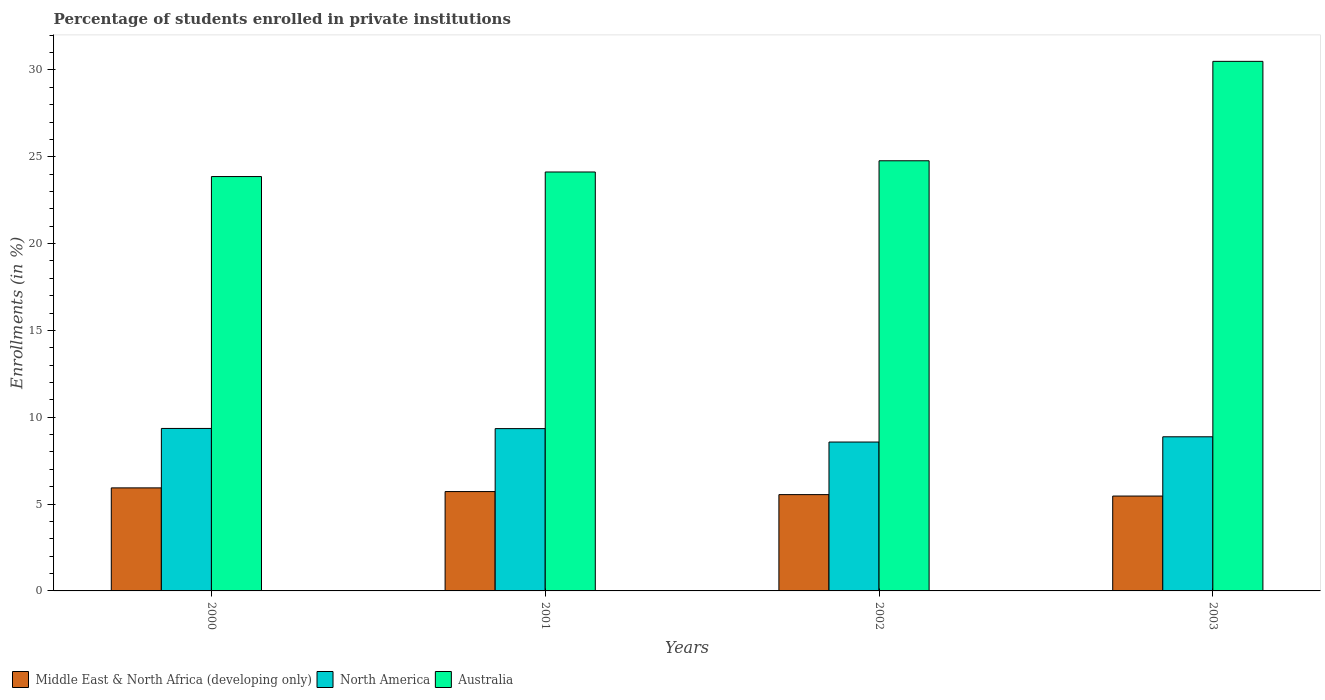How many groups of bars are there?
Your answer should be very brief. 4. How many bars are there on the 3rd tick from the left?
Your answer should be very brief. 3. How many bars are there on the 4th tick from the right?
Provide a succinct answer. 3. What is the label of the 2nd group of bars from the left?
Make the answer very short. 2001. In how many cases, is the number of bars for a given year not equal to the number of legend labels?
Give a very brief answer. 0. What is the percentage of trained teachers in Australia in 2000?
Make the answer very short. 23.86. Across all years, what is the maximum percentage of trained teachers in Australia?
Offer a terse response. 30.49. Across all years, what is the minimum percentage of trained teachers in Middle East & North Africa (developing only)?
Provide a succinct answer. 5.46. In which year was the percentage of trained teachers in Australia maximum?
Ensure brevity in your answer.  2003. What is the total percentage of trained teachers in North America in the graph?
Provide a succinct answer. 36.15. What is the difference between the percentage of trained teachers in Middle East & North Africa (developing only) in 2002 and that in 2003?
Provide a short and direct response. 0.08. What is the difference between the percentage of trained teachers in North America in 2001 and the percentage of trained teachers in Australia in 2002?
Your answer should be very brief. -15.42. What is the average percentage of trained teachers in Middle East & North Africa (developing only) per year?
Make the answer very short. 5.67. In the year 2002, what is the difference between the percentage of trained teachers in Middle East & North Africa (developing only) and percentage of trained teachers in North America?
Your response must be concise. -3.03. What is the ratio of the percentage of trained teachers in Australia in 2000 to that in 2001?
Provide a succinct answer. 0.99. What is the difference between the highest and the second highest percentage of trained teachers in Australia?
Keep it short and to the point. 5.72. What is the difference between the highest and the lowest percentage of trained teachers in Middle East & North Africa (developing only)?
Provide a succinct answer. 0.47. Is the sum of the percentage of trained teachers in North America in 2000 and 2002 greater than the maximum percentage of trained teachers in Australia across all years?
Your response must be concise. No. What does the 2nd bar from the left in 2002 represents?
Make the answer very short. North America. What does the 2nd bar from the right in 2002 represents?
Keep it short and to the point. North America. Is it the case that in every year, the sum of the percentage of trained teachers in Australia and percentage of trained teachers in Middle East & North Africa (developing only) is greater than the percentage of trained teachers in North America?
Keep it short and to the point. Yes. How many years are there in the graph?
Ensure brevity in your answer.  4. What is the difference between two consecutive major ticks on the Y-axis?
Your answer should be very brief. 5. Does the graph contain grids?
Offer a very short reply. No. Where does the legend appear in the graph?
Your answer should be compact. Bottom left. How are the legend labels stacked?
Your response must be concise. Horizontal. What is the title of the graph?
Offer a very short reply. Percentage of students enrolled in private institutions. What is the label or title of the Y-axis?
Keep it short and to the point. Enrollments (in %). What is the Enrollments (in %) in Middle East & North Africa (developing only) in 2000?
Your response must be concise. 5.93. What is the Enrollments (in %) of North America in 2000?
Keep it short and to the point. 9.36. What is the Enrollments (in %) in Australia in 2000?
Ensure brevity in your answer.  23.86. What is the Enrollments (in %) in Middle East & North Africa (developing only) in 2001?
Offer a terse response. 5.72. What is the Enrollments (in %) of North America in 2001?
Your answer should be compact. 9.35. What is the Enrollments (in %) in Australia in 2001?
Provide a succinct answer. 24.12. What is the Enrollments (in %) in Middle East & North Africa (developing only) in 2002?
Your answer should be very brief. 5.55. What is the Enrollments (in %) of North America in 2002?
Keep it short and to the point. 8.57. What is the Enrollments (in %) of Australia in 2002?
Provide a succinct answer. 24.77. What is the Enrollments (in %) in Middle East & North Africa (developing only) in 2003?
Your answer should be very brief. 5.46. What is the Enrollments (in %) of North America in 2003?
Provide a short and direct response. 8.87. What is the Enrollments (in %) in Australia in 2003?
Ensure brevity in your answer.  30.49. Across all years, what is the maximum Enrollments (in %) of Middle East & North Africa (developing only)?
Your response must be concise. 5.93. Across all years, what is the maximum Enrollments (in %) of North America?
Provide a short and direct response. 9.36. Across all years, what is the maximum Enrollments (in %) in Australia?
Give a very brief answer. 30.49. Across all years, what is the minimum Enrollments (in %) of Middle East & North Africa (developing only)?
Make the answer very short. 5.46. Across all years, what is the minimum Enrollments (in %) of North America?
Ensure brevity in your answer.  8.57. Across all years, what is the minimum Enrollments (in %) of Australia?
Ensure brevity in your answer.  23.86. What is the total Enrollments (in %) of Middle East & North Africa (developing only) in the graph?
Ensure brevity in your answer.  22.66. What is the total Enrollments (in %) in North America in the graph?
Your answer should be very brief. 36.15. What is the total Enrollments (in %) in Australia in the graph?
Provide a succinct answer. 103.24. What is the difference between the Enrollments (in %) of Middle East & North Africa (developing only) in 2000 and that in 2001?
Ensure brevity in your answer.  0.21. What is the difference between the Enrollments (in %) in North America in 2000 and that in 2001?
Your answer should be very brief. 0.01. What is the difference between the Enrollments (in %) of Australia in 2000 and that in 2001?
Give a very brief answer. -0.26. What is the difference between the Enrollments (in %) of Middle East & North Africa (developing only) in 2000 and that in 2002?
Offer a terse response. 0.39. What is the difference between the Enrollments (in %) in North America in 2000 and that in 2002?
Keep it short and to the point. 0.78. What is the difference between the Enrollments (in %) of Australia in 2000 and that in 2002?
Keep it short and to the point. -0.91. What is the difference between the Enrollments (in %) of Middle East & North Africa (developing only) in 2000 and that in 2003?
Make the answer very short. 0.47. What is the difference between the Enrollments (in %) of North America in 2000 and that in 2003?
Provide a succinct answer. 0.48. What is the difference between the Enrollments (in %) in Australia in 2000 and that in 2003?
Ensure brevity in your answer.  -6.63. What is the difference between the Enrollments (in %) in Middle East & North Africa (developing only) in 2001 and that in 2002?
Your response must be concise. 0.18. What is the difference between the Enrollments (in %) in North America in 2001 and that in 2002?
Keep it short and to the point. 0.77. What is the difference between the Enrollments (in %) of Australia in 2001 and that in 2002?
Offer a very short reply. -0.65. What is the difference between the Enrollments (in %) of Middle East & North Africa (developing only) in 2001 and that in 2003?
Provide a succinct answer. 0.26. What is the difference between the Enrollments (in %) of North America in 2001 and that in 2003?
Give a very brief answer. 0.47. What is the difference between the Enrollments (in %) of Australia in 2001 and that in 2003?
Ensure brevity in your answer.  -6.37. What is the difference between the Enrollments (in %) of Middle East & North Africa (developing only) in 2002 and that in 2003?
Provide a succinct answer. 0.08. What is the difference between the Enrollments (in %) in North America in 2002 and that in 2003?
Keep it short and to the point. -0.3. What is the difference between the Enrollments (in %) in Australia in 2002 and that in 2003?
Your answer should be very brief. -5.72. What is the difference between the Enrollments (in %) of Middle East & North Africa (developing only) in 2000 and the Enrollments (in %) of North America in 2001?
Give a very brief answer. -3.41. What is the difference between the Enrollments (in %) of Middle East & North Africa (developing only) in 2000 and the Enrollments (in %) of Australia in 2001?
Offer a very short reply. -18.19. What is the difference between the Enrollments (in %) of North America in 2000 and the Enrollments (in %) of Australia in 2001?
Your answer should be very brief. -14.77. What is the difference between the Enrollments (in %) of Middle East & North Africa (developing only) in 2000 and the Enrollments (in %) of North America in 2002?
Offer a very short reply. -2.64. What is the difference between the Enrollments (in %) of Middle East & North Africa (developing only) in 2000 and the Enrollments (in %) of Australia in 2002?
Ensure brevity in your answer.  -18.84. What is the difference between the Enrollments (in %) in North America in 2000 and the Enrollments (in %) in Australia in 2002?
Your answer should be very brief. -15.41. What is the difference between the Enrollments (in %) of Middle East & North Africa (developing only) in 2000 and the Enrollments (in %) of North America in 2003?
Ensure brevity in your answer.  -2.94. What is the difference between the Enrollments (in %) in Middle East & North Africa (developing only) in 2000 and the Enrollments (in %) in Australia in 2003?
Offer a terse response. -24.56. What is the difference between the Enrollments (in %) of North America in 2000 and the Enrollments (in %) of Australia in 2003?
Your answer should be very brief. -21.14. What is the difference between the Enrollments (in %) of Middle East & North Africa (developing only) in 2001 and the Enrollments (in %) of North America in 2002?
Your answer should be compact. -2.85. What is the difference between the Enrollments (in %) in Middle East & North Africa (developing only) in 2001 and the Enrollments (in %) in Australia in 2002?
Keep it short and to the point. -19.05. What is the difference between the Enrollments (in %) of North America in 2001 and the Enrollments (in %) of Australia in 2002?
Keep it short and to the point. -15.42. What is the difference between the Enrollments (in %) of Middle East & North Africa (developing only) in 2001 and the Enrollments (in %) of North America in 2003?
Your response must be concise. -3.15. What is the difference between the Enrollments (in %) in Middle East & North Africa (developing only) in 2001 and the Enrollments (in %) in Australia in 2003?
Your response must be concise. -24.77. What is the difference between the Enrollments (in %) in North America in 2001 and the Enrollments (in %) in Australia in 2003?
Keep it short and to the point. -21.15. What is the difference between the Enrollments (in %) in Middle East & North Africa (developing only) in 2002 and the Enrollments (in %) in North America in 2003?
Your answer should be compact. -3.33. What is the difference between the Enrollments (in %) of Middle East & North Africa (developing only) in 2002 and the Enrollments (in %) of Australia in 2003?
Ensure brevity in your answer.  -24.95. What is the difference between the Enrollments (in %) in North America in 2002 and the Enrollments (in %) in Australia in 2003?
Offer a very short reply. -21.92. What is the average Enrollments (in %) in Middle East & North Africa (developing only) per year?
Keep it short and to the point. 5.67. What is the average Enrollments (in %) in North America per year?
Offer a very short reply. 9.04. What is the average Enrollments (in %) in Australia per year?
Make the answer very short. 25.81. In the year 2000, what is the difference between the Enrollments (in %) of Middle East & North Africa (developing only) and Enrollments (in %) of North America?
Offer a very short reply. -3.42. In the year 2000, what is the difference between the Enrollments (in %) of Middle East & North Africa (developing only) and Enrollments (in %) of Australia?
Make the answer very short. -17.93. In the year 2000, what is the difference between the Enrollments (in %) in North America and Enrollments (in %) in Australia?
Ensure brevity in your answer.  -14.5. In the year 2001, what is the difference between the Enrollments (in %) of Middle East & North Africa (developing only) and Enrollments (in %) of North America?
Your response must be concise. -3.62. In the year 2001, what is the difference between the Enrollments (in %) of Middle East & North Africa (developing only) and Enrollments (in %) of Australia?
Offer a very short reply. -18.4. In the year 2001, what is the difference between the Enrollments (in %) in North America and Enrollments (in %) in Australia?
Make the answer very short. -14.78. In the year 2002, what is the difference between the Enrollments (in %) of Middle East & North Africa (developing only) and Enrollments (in %) of North America?
Give a very brief answer. -3.03. In the year 2002, what is the difference between the Enrollments (in %) of Middle East & North Africa (developing only) and Enrollments (in %) of Australia?
Keep it short and to the point. -19.22. In the year 2002, what is the difference between the Enrollments (in %) in North America and Enrollments (in %) in Australia?
Provide a short and direct response. -16.2. In the year 2003, what is the difference between the Enrollments (in %) of Middle East & North Africa (developing only) and Enrollments (in %) of North America?
Keep it short and to the point. -3.41. In the year 2003, what is the difference between the Enrollments (in %) in Middle East & North Africa (developing only) and Enrollments (in %) in Australia?
Provide a succinct answer. -25.03. In the year 2003, what is the difference between the Enrollments (in %) of North America and Enrollments (in %) of Australia?
Your answer should be very brief. -21.62. What is the ratio of the Enrollments (in %) in Middle East & North Africa (developing only) in 2000 to that in 2001?
Ensure brevity in your answer.  1.04. What is the ratio of the Enrollments (in %) in North America in 2000 to that in 2001?
Your answer should be compact. 1. What is the ratio of the Enrollments (in %) in Australia in 2000 to that in 2001?
Ensure brevity in your answer.  0.99. What is the ratio of the Enrollments (in %) in Middle East & North Africa (developing only) in 2000 to that in 2002?
Your response must be concise. 1.07. What is the ratio of the Enrollments (in %) of North America in 2000 to that in 2002?
Your response must be concise. 1.09. What is the ratio of the Enrollments (in %) of Australia in 2000 to that in 2002?
Give a very brief answer. 0.96. What is the ratio of the Enrollments (in %) of Middle East & North Africa (developing only) in 2000 to that in 2003?
Offer a very short reply. 1.09. What is the ratio of the Enrollments (in %) in North America in 2000 to that in 2003?
Ensure brevity in your answer.  1.05. What is the ratio of the Enrollments (in %) of Australia in 2000 to that in 2003?
Keep it short and to the point. 0.78. What is the ratio of the Enrollments (in %) in Middle East & North Africa (developing only) in 2001 to that in 2002?
Your answer should be very brief. 1.03. What is the ratio of the Enrollments (in %) in North America in 2001 to that in 2002?
Provide a succinct answer. 1.09. What is the ratio of the Enrollments (in %) in Australia in 2001 to that in 2002?
Offer a terse response. 0.97. What is the ratio of the Enrollments (in %) of Middle East & North Africa (developing only) in 2001 to that in 2003?
Give a very brief answer. 1.05. What is the ratio of the Enrollments (in %) in North America in 2001 to that in 2003?
Your answer should be very brief. 1.05. What is the ratio of the Enrollments (in %) of Australia in 2001 to that in 2003?
Offer a very short reply. 0.79. What is the ratio of the Enrollments (in %) of Middle East & North Africa (developing only) in 2002 to that in 2003?
Give a very brief answer. 1.02. What is the ratio of the Enrollments (in %) of North America in 2002 to that in 2003?
Offer a very short reply. 0.97. What is the ratio of the Enrollments (in %) of Australia in 2002 to that in 2003?
Your answer should be very brief. 0.81. What is the difference between the highest and the second highest Enrollments (in %) of Middle East & North Africa (developing only)?
Ensure brevity in your answer.  0.21. What is the difference between the highest and the second highest Enrollments (in %) in North America?
Give a very brief answer. 0.01. What is the difference between the highest and the second highest Enrollments (in %) in Australia?
Your answer should be compact. 5.72. What is the difference between the highest and the lowest Enrollments (in %) in Middle East & North Africa (developing only)?
Your answer should be compact. 0.47. What is the difference between the highest and the lowest Enrollments (in %) of North America?
Provide a succinct answer. 0.78. What is the difference between the highest and the lowest Enrollments (in %) in Australia?
Your response must be concise. 6.63. 